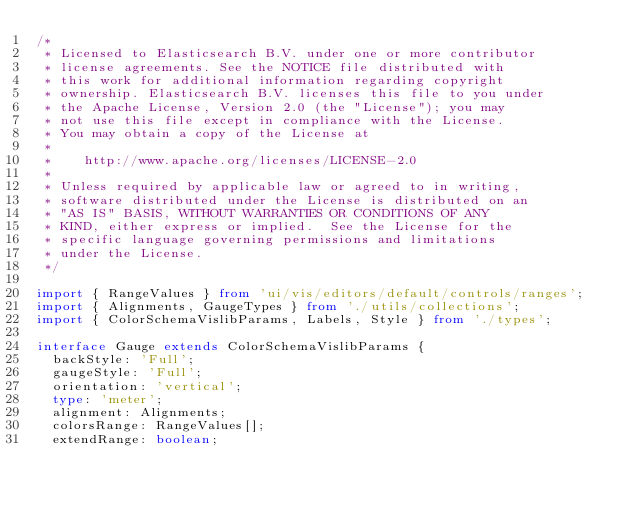Convert code to text. <code><loc_0><loc_0><loc_500><loc_500><_TypeScript_>/*
 * Licensed to Elasticsearch B.V. under one or more contributor
 * license agreements. See the NOTICE file distributed with
 * this work for additional information regarding copyright
 * ownership. Elasticsearch B.V. licenses this file to you under
 * the Apache License, Version 2.0 (the "License"); you may
 * not use this file except in compliance with the License.
 * You may obtain a copy of the License at
 *
 *    http://www.apache.org/licenses/LICENSE-2.0
 *
 * Unless required by applicable law or agreed to in writing,
 * software distributed under the License is distributed on an
 * "AS IS" BASIS, WITHOUT WARRANTIES OR CONDITIONS OF ANY
 * KIND, either express or implied.  See the License for the
 * specific language governing permissions and limitations
 * under the License.
 */

import { RangeValues } from 'ui/vis/editors/default/controls/ranges';
import { Alignments, GaugeTypes } from './utils/collections';
import { ColorSchemaVislibParams, Labels, Style } from './types';

interface Gauge extends ColorSchemaVislibParams {
  backStyle: 'Full';
  gaugeStyle: 'Full';
  orientation: 'vertical';
  type: 'meter';
  alignment: Alignments;
  colorsRange: RangeValues[];
  extendRange: boolean;</code> 